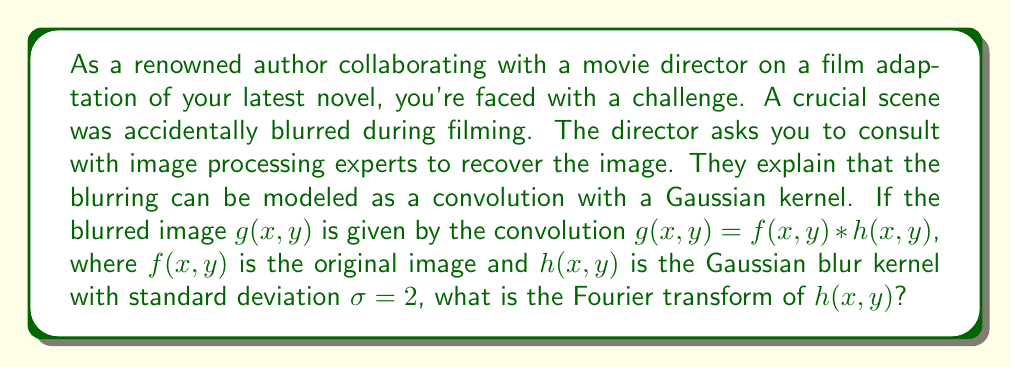Could you help me with this problem? Let's approach this step-by-step:

1) The Gaussian blur kernel in 2D is given by:

   $$h(x,y) = \frac{1}{2\pi\sigma^2} e^{-\frac{x^2+y^2}{2\sigma^2}}$$

2) We need to find the Fourier transform of this function. The 2D Fourier transform is defined as:

   $$H(u,v) = \int_{-\infty}^{\infty} \int_{-\infty}^{\infty} h(x,y) e^{-j2\pi(ux+vy)} dx dy$$

3) Substituting the Gaussian function into this integral:

   $$H(u,v) = \frac{1}{2\pi\sigma^2} \int_{-\infty}^{\infty} \int_{-\infty}^{\infty} e^{-\frac{x^2+y^2}{2\sigma^2}} e^{-j2\pi(ux+vy)} dx dy$$

4) This integral can be separated into two parts:

   $$H(u,v) = \frac{1}{2\pi\sigma^2} \int_{-\infty}^{\infty} e^{-\frac{x^2}{2\sigma^2}} e^{-j2\pi ux} dx \int_{-\infty}^{\infty} e^{-\frac{y^2}{2\sigma^2}} e^{-j2\pi vy} dy$$

5) Each of these integrals is the Fourier transform of a 1D Gaussian function, which is known to be another Gaussian:

   $$H(u,v) = e^{-2\pi^2\sigma^2(u^2+v^2)}$$

6) Substituting $\sigma = 2$:

   $$H(u,v) = e^{-8\pi^2(u^2+v^2)}$$

This is the Fourier transform of the Gaussian blur kernel.
Answer: $H(u,v) = e^{-8\pi^2(u^2+v^2)}$ 